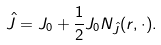Convert formula to latex. <formula><loc_0><loc_0><loc_500><loc_500>\hat { J } = J _ { 0 } + \frac { 1 } { 2 } J _ { 0 } N _ { \hat { J } } ( r , \cdot ) .</formula> 